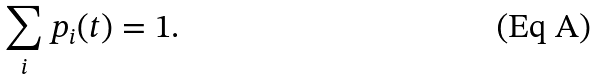Convert formula to latex. <formula><loc_0><loc_0><loc_500><loc_500>\sum _ { i } p _ { i } ( t ) = 1 .</formula> 